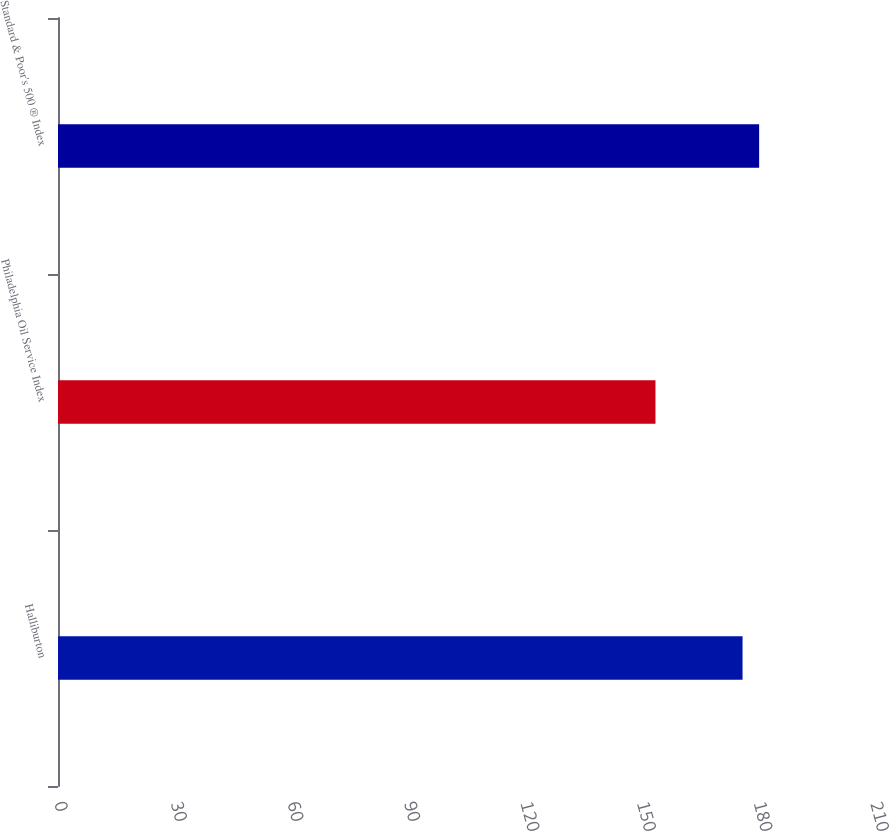Convert chart. <chart><loc_0><loc_0><loc_500><loc_500><bar_chart><fcel>Halliburton<fcel>Philadelphia Oil Service Index<fcel>Standard & Poor's 500 ® Index<nl><fcel>176.17<fcel>153.76<fcel>180.44<nl></chart> 